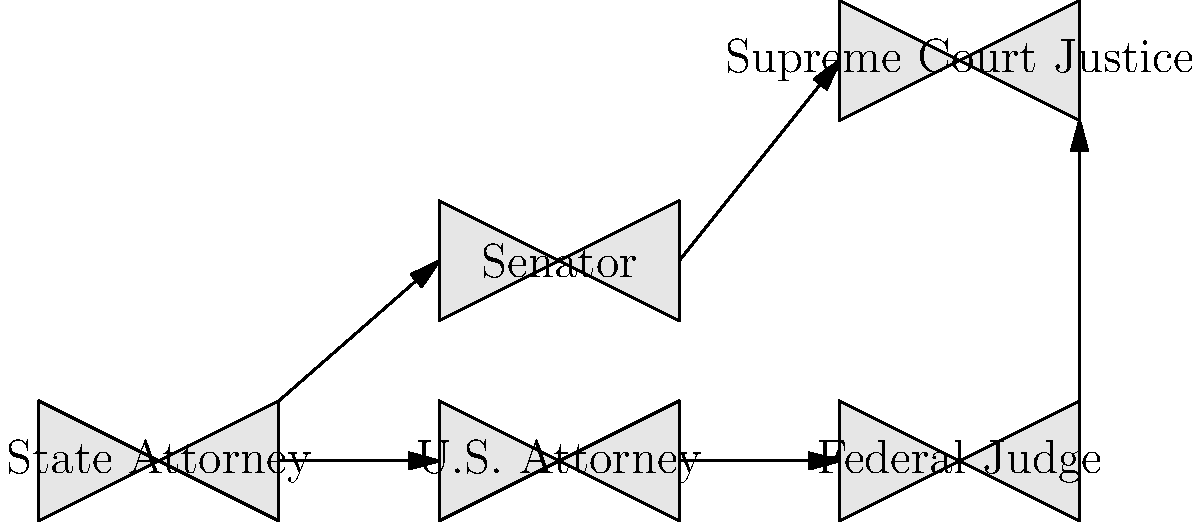Based on the organizational chart depicting career progression paths for Democratic lawyers, which position is most likely to lead directly to becoming a Supreme Court Justice? To answer this question, we need to analyze the career progression paths shown in the organizational chart:

1. The chart shows five positions: State Attorney, U.S. Attorney, Federal Judge, Senator, and Supreme Court Justice.

2. We can see arrows indicating possible career progressions:
   - State Attorney can lead to U.S. Attorney or Senator
   - U.S. Attorney can lead to Federal Judge
   - Federal Judge can lead to Supreme Court Justice
   - Senator can lead to Supreme Court Justice

3. There are two direct paths to becoming a Supreme Court Justice:
   - From Federal Judge
   - From Senator

4. However, the path from Federal Judge to Supreme Court Justice is more common and traditional for legal professionals.

5. The position of Senator, while it can lead to a Supreme Court appointment, is not primarily a legal position but a political one.

6. Federal Judges have extensive experience in interpreting and applying federal law, which is crucial for Supreme Court Justices.

Therefore, based on the career progression paths shown and the nature of the positions, the role of Federal Judge is most likely to lead directly to becoming a Supreme Court Justice.
Answer: Federal Judge 